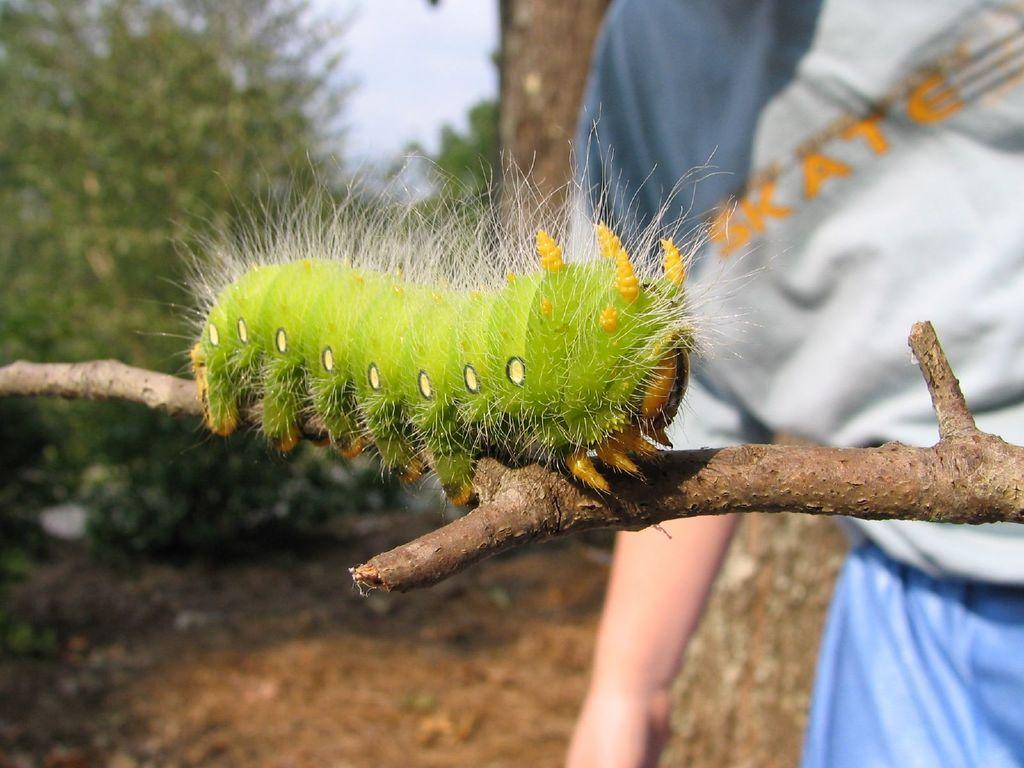What is the main subject of the image? There is a caterpillar on a branch in the image. Are there any other living beings in the image? Yes, there is a person in the image. What can be seen in the background of the image? There are trees in the background of the image. What type of beam is being used by the caterpillar to climb the branch in the image? There is no beam present in the image; the caterpillar is climbing the branch using its legs. 